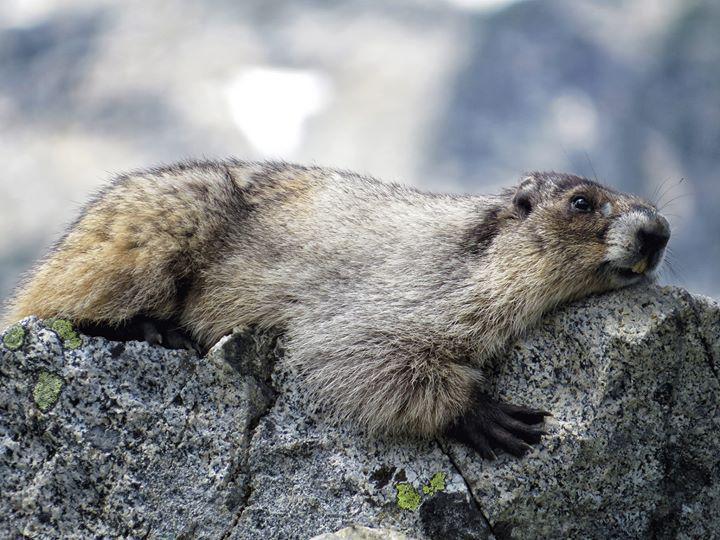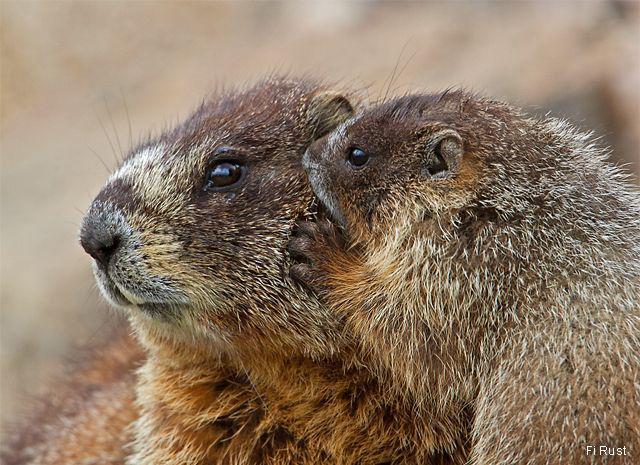The first image is the image on the left, the second image is the image on the right. Evaluate the accuracy of this statement regarding the images: "There is at least one prairie dog standing on its hind legs.". Is it true? Answer yes or no. No. 